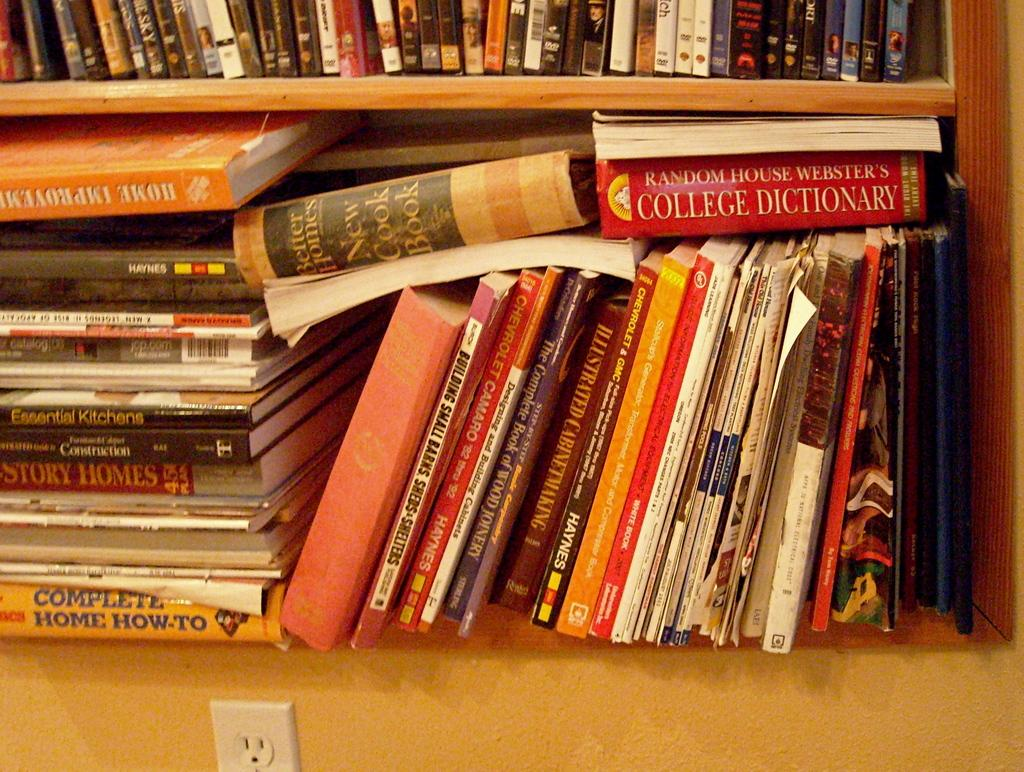<image>
Provide a brief description of the given image. A copy of Random House Webster's College Dictionary sits on top of a stack of other books on a shelf. 